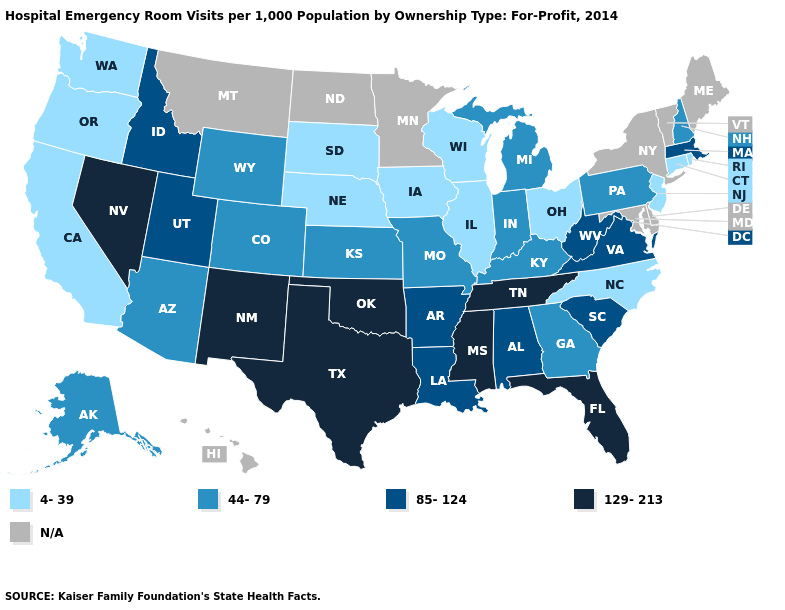What is the value of Ohio?
Short answer required. 4-39. Which states have the lowest value in the South?
Write a very short answer. North Carolina. Does Texas have the highest value in the USA?
Keep it brief. Yes. Name the states that have a value in the range N/A?
Answer briefly. Delaware, Hawaii, Maine, Maryland, Minnesota, Montana, New York, North Dakota, Vermont. Name the states that have a value in the range 85-124?
Short answer required. Alabama, Arkansas, Idaho, Louisiana, Massachusetts, South Carolina, Utah, Virginia, West Virginia. What is the highest value in states that border Tennessee?
Concise answer only. 129-213. What is the value of Washington?
Keep it brief. 4-39. What is the highest value in the USA?
Answer briefly. 129-213. What is the value of Alabama?
Write a very short answer. 85-124. Name the states that have a value in the range 44-79?
Keep it brief. Alaska, Arizona, Colorado, Georgia, Indiana, Kansas, Kentucky, Michigan, Missouri, New Hampshire, Pennsylvania, Wyoming. What is the value of Virginia?
Write a very short answer. 85-124. Among the states that border Delaware , which have the lowest value?
Be succinct. New Jersey. Does the map have missing data?
Short answer required. Yes. Name the states that have a value in the range N/A?
Keep it brief. Delaware, Hawaii, Maine, Maryland, Minnesota, Montana, New York, North Dakota, Vermont. 